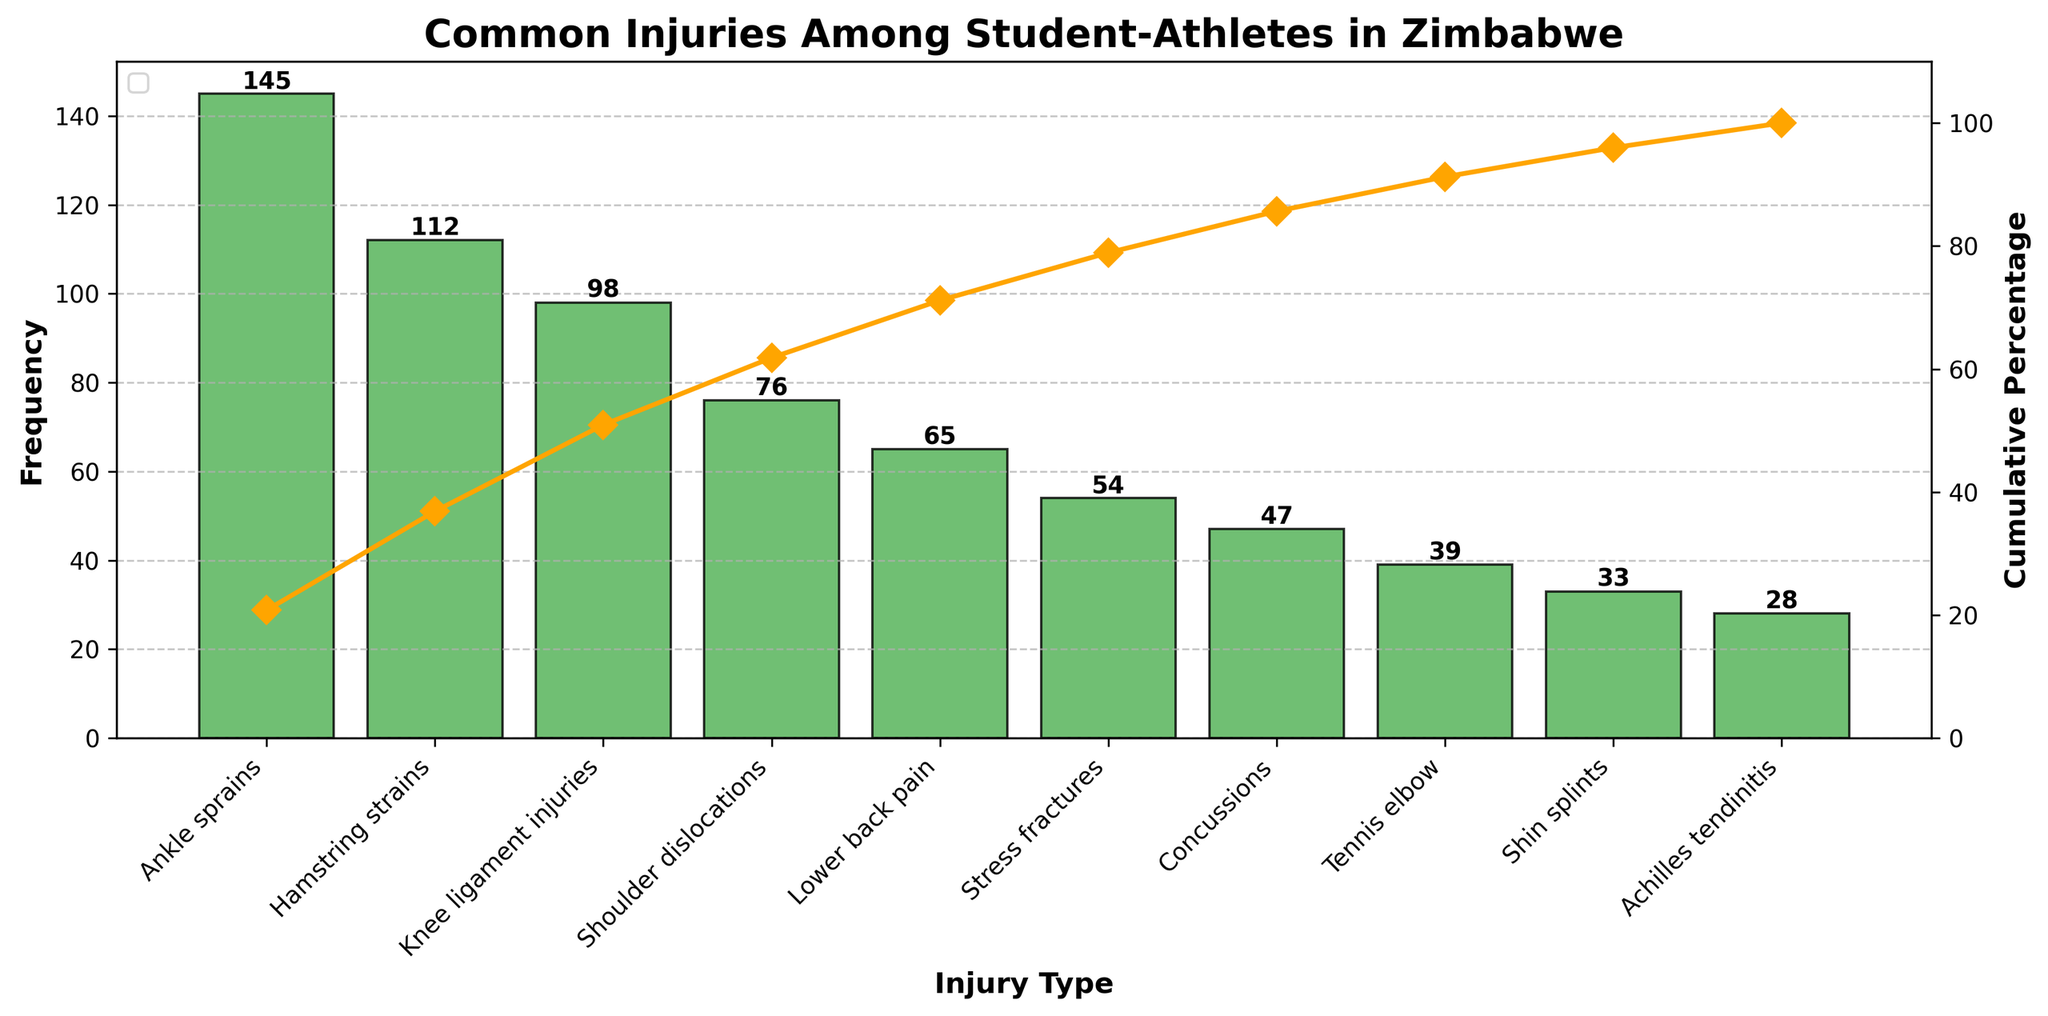What's the title of the chart? The title of the chart is typically located at the top and provides brief information about the purpose of the chart. In this case, it reads "Common Injuries Among Student-Athletes in Zimbabwe."
Answer: Common Injuries Among Student-Athletes in Zimbabwe Which injury type has the highest frequency? To determine the injury type with the highest frequency, look at the tallest bar. The tallest bar corresponds to 'Ankle sprains', indicating it has the highest frequency.
Answer: Ankle sprains What injury type has the lowest frequency, and what is that frequency? Identify the shortest bar to find the injury type with the lowest frequency. This corresponds to 'Achilles tendinitis,' with a frequency of 28.
Answer: Achilles tendinitis, 28 What is the cumulative percentage of the top three injuries? The cumulative percentage can be found on the line plot for the top three bars: 'Ankle sprains,' 'Hamstring strains,' and 'Knee ligament injuries.' Adding their frequencies gives 355. Dividing by the total frequency sum (697) and multiplying by 100 gives approximately 50.9%.
Answer: 50.9% Which injuries together make up more than 80% of the total injuries? To find which injuries make up more than 80%, refer to the line plot showing the cumulative percentage. 'Ankle sprains,' 'Hamstring strains,' 'Knee ligament injuries,' 'Shoulder dislocations,' 'Lower back pain,' and 'Stress fractures' together exceed 80% on the cumulative percentage line.
Answer: Ankle sprains, Hamstring strains, Knee ligament injuries, Shoulder dislocations, Lower back pain, Stress fractures What is the total number of injuries recorded in the chart? Sum all the frequencies of the injuries listed in the chart (145 + 112 + 98 + 76 + 65 + 54 + 47 + 39 + 33 + 28) = 697.
Answer: 697 How does the frequency of 'Concussions' compare to 'Tennis elbow'? Identify the frequencies of 'Concussions' and 'Tennis elbow' from the bars. 'Concussions' has a frequency of 47, while 'Tennis elbow' has a frequency of 39. Comparing these, 'Concussions' has a higher frequency.
Answer: Concussions has a higher frequency What percentage of the total injuries are 'Lower back pain' and 'Stress fractures'? Sum the frequencies of 'Lower back pain' and 'Stress fractures' (65 + 54 = 119), then divide by the total number of injuries (697) and multiply by 100 to get approximately 17%.
Answer: 17% Which injury appears fourth most frequently? Rank the injuries by the height of their bars and identify the fourth rank. 'Shoulder dislocations' appear as the fourth most frequent injury.
Answer: Shoulder dislocations 